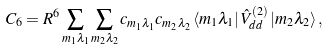Convert formula to latex. <formula><loc_0><loc_0><loc_500><loc_500>C _ { 6 } = R ^ { 6 } \sum _ { m _ { 1 } \lambda _ { 1 } } \sum _ { m _ { 2 } \lambda _ { 2 } } c _ { m _ { 1 } \lambda _ { 1 } } c _ { m _ { 2 } \lambda _ { 2 } } \left \langle m _ { 1 } \lambda _ { 1 } \right | \hat { V } _ { d d } ^ { ( 2 ) } \left | m _ { 2 } \lambda _ { 2 } \right \rangle ,</formula> 